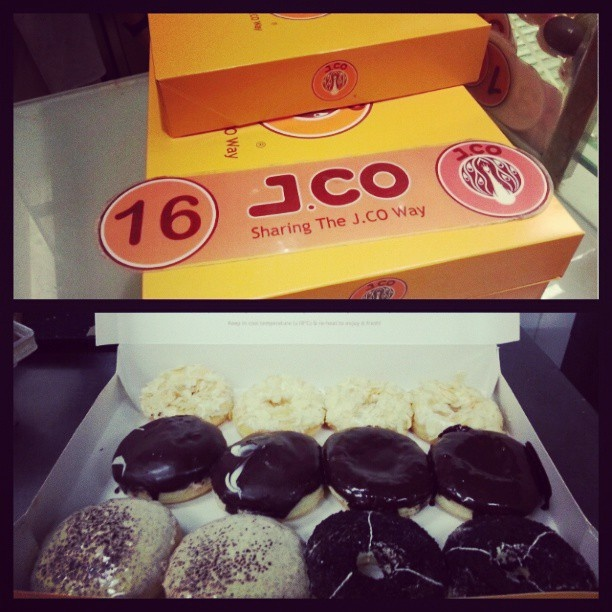Describe the objects in this image and their specific colors. I can see donut in black, gray, darkgray, and purple tones, donut in black, gray, and purple tones, donut in black, darkgray, and gray tones, donut in black, darkgray, purple, and gray tones, and donut in black, purple, and gray tones in this image. 